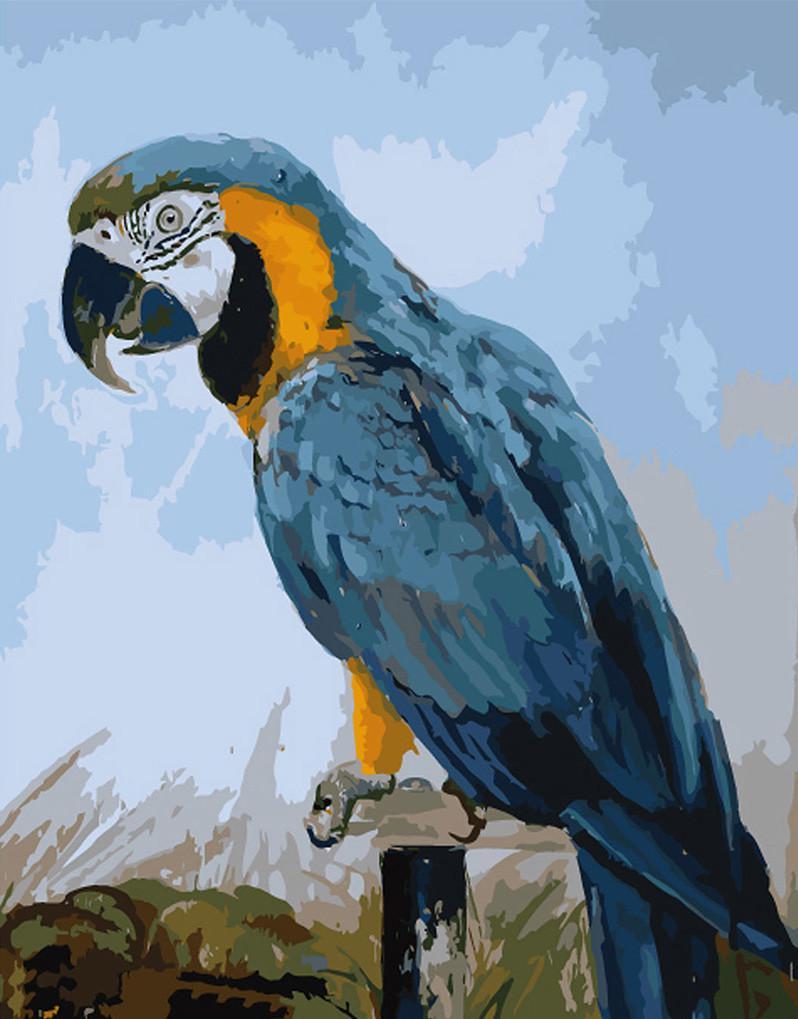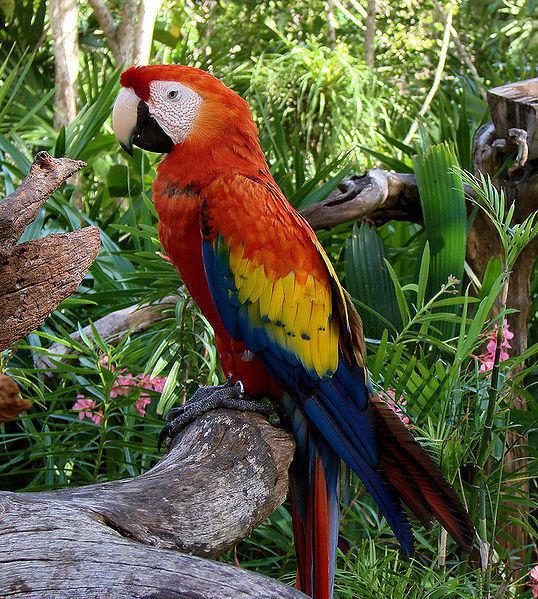The first image is the image on the left, the second image is the image on the right. Given the left and right images, does the statement "There are exactly two birds in the image on the right." hold true? Answer yes or no. No. 